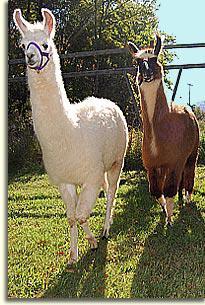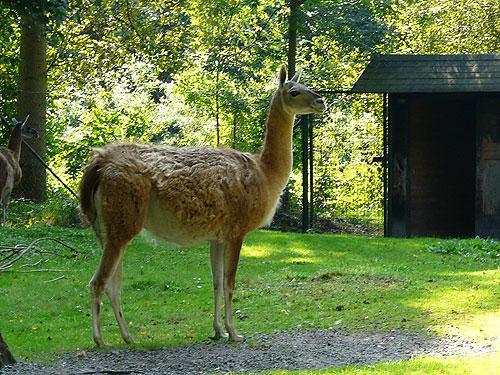The first image is the image on the left, the second image is the image on the right. Analyze the images presented: Is the assertion "Four or fewer llamas are visible." valid? Answer yes or no. Yes. The first image is the image on the left, the second image is the image on the right. Analyze the images presented: Is the assertion "Three or more alpacas are standing together in a field in each picture." valid? Answer yes or no. No. 